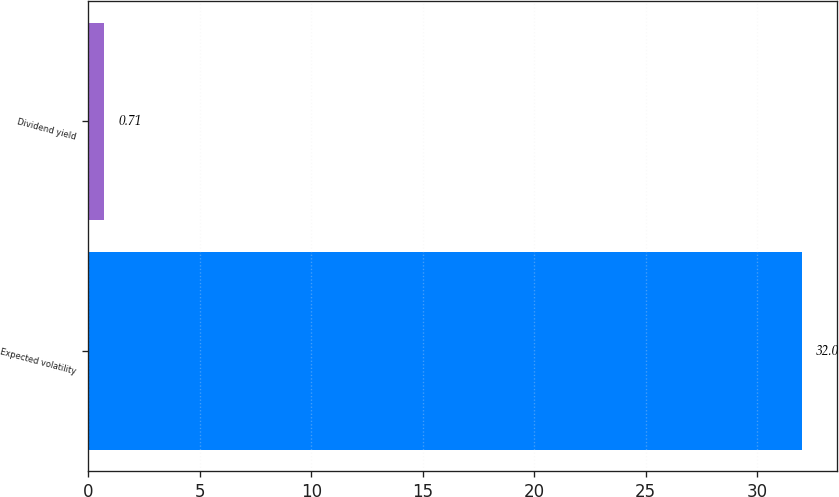Convert chart. <chart><loc_0><loc_0><loc_500><loc_500><bar_chart><fcel>Expected volatility<fcel>Dividend yield<nl><fcel>32<fcel>0.71<nl></chart> 